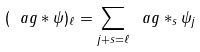Convert formula to latex. <formula><loc_0><loc_0><loc_500><loc_500>( \ a g \ast \psi ) _ { \ell } = \sum _ { j + s = \ell } \ a g \ast _ { s } \psi _ { j }</formula> 